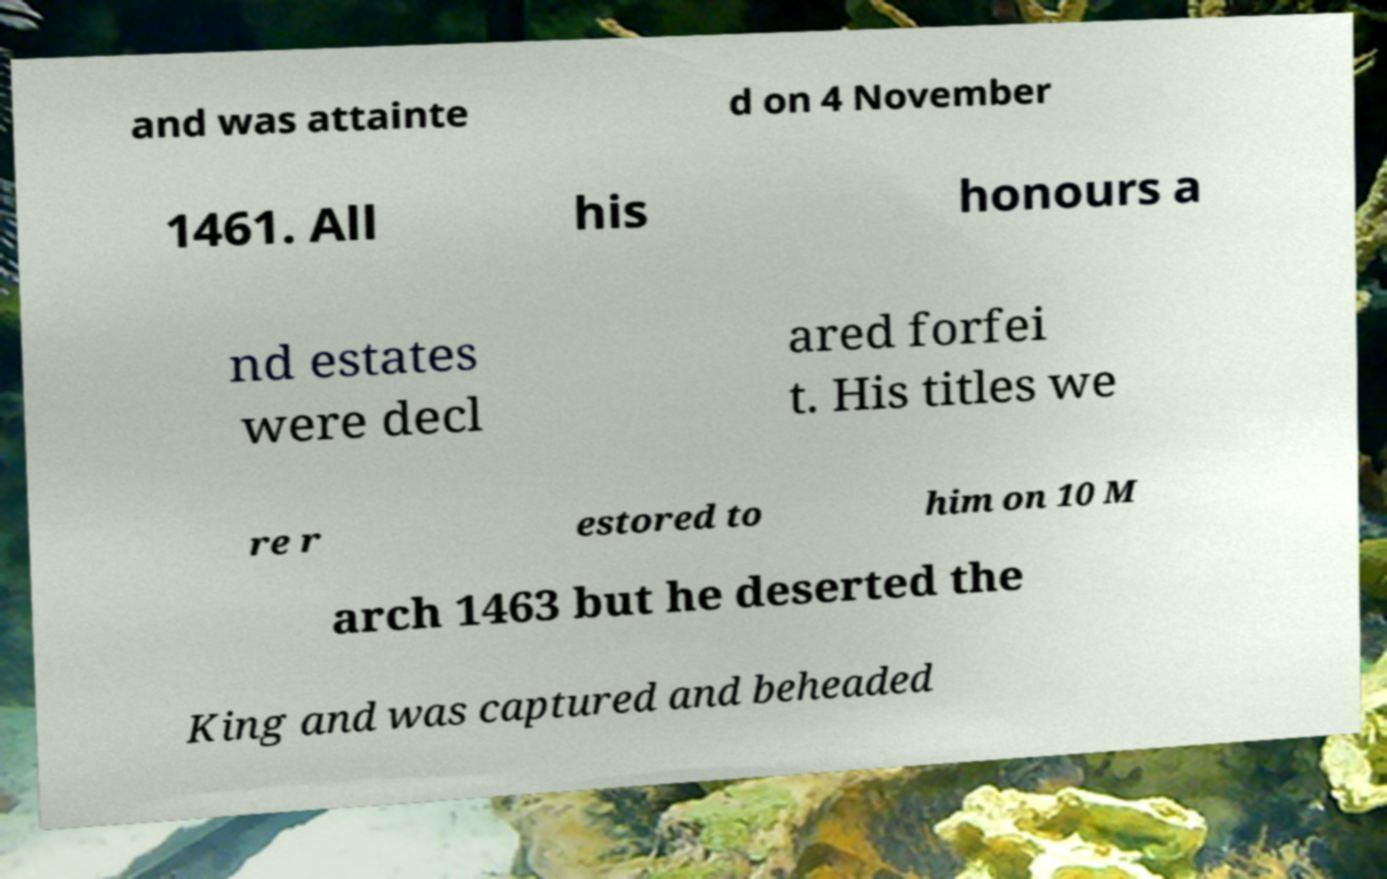Can you read and provide the text displayed in the image?This photo seems to have some interesting text. Can you extract and type it out for me? and was attainte d on 4 November 1461. All his honours a nd estates were decl ared forfei t. His titles we re r estored to him on 10 M arch 1463 but he deserted the King and was captured and beheaded 